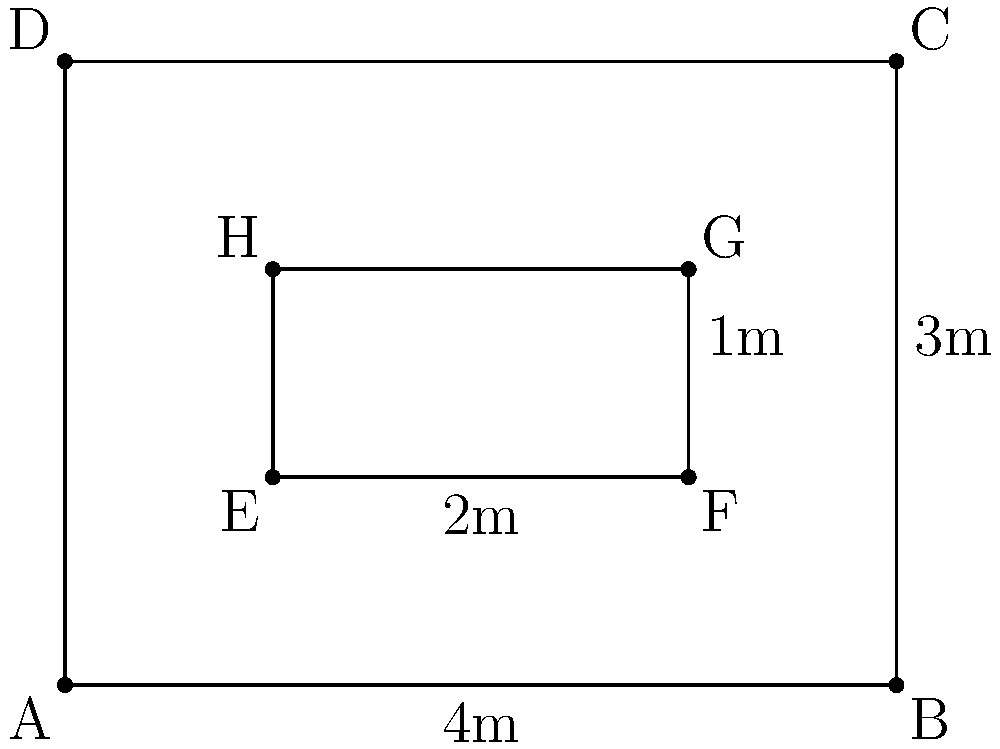For your Star Wars-themed production, you need to create a scaled-down version of the Millennium Falcon cockpit. The original dimensions are represented by rectangle ABCD, with a width of 4m and a height of 3m. You want to create a smaller set piece represented by rectangle EFGH. If vector $\vec{AE} = \begin{pmatrix} 1 \\ 1 \end{pmatrix}$, what transformation matrix would you use to map the original cockpit dimensions to the smaller set piece? To find the transformation matrix, we need to follow these steps:

1) First, observe that rectangle EFGH is a scaled and translated version of ABCD.

2) The translation vector is $\vec{AE} = \begin{pmatrix} 1 \\ 1 \end{pmatrix}$.

3) To find the scaling factor, we need to compare the dimensions:
   Original width: 4m
   New width: 2m
   Scaling factor = 2/4 = 1/2 = 0.5

4) The transformation can be represented as a combination of scaling and translation:
   $T(\vec{x}) = S\vec{x} + \vec{b}$
   where $S$ is the scaling matrix and $\vec{b}$ is the translation vector.

5) The scaling matrix for uniform scaling by 0.5 is:
   $S = \begin{pmatrix} 0.5 & 0 \\ 0 & 0.5 \end{pmatrix}$

6) The complete transformation is:
   $T(\vec{x}) = \begin{pmatrix} 0.5 & 0 \\ 0 & 0.5 \end{pmatrix}\vec{x} + \begin{pmatrix} 1 \\ 1 \end{pmatrix}$

7) This can be represented as a single matrix operation:
   $T(\vec{x}) = \begin{pmatrix} 0.5 & 0 & 1 \\ 0 & 0.5 & 1 \\ 0 & 0 & 1 \end{pmatrix}\begin{pmatrix} x \\ y \\ 1 \end{pmatrix}$

Therefore, the transformation matrix is $\begin{pmatrix} 0.5 & 0 & 1 \\ 0 & 0.5 & 1 \\ 0 & 0 & 1 \end{pmatrix}$.
Answer: $\begin{pmatrix} 0.5 & 0 & 1 \\ 0 & 0.5 & 1 \\ 0 & 0 & 1 \end{pmatrix}$ 